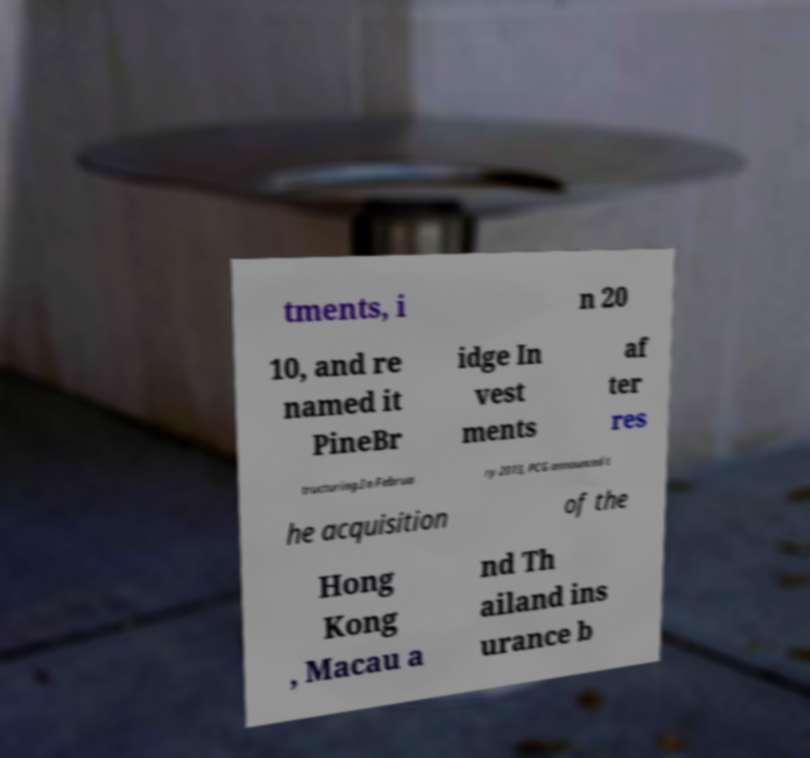Can you accurately transcribe the text from the provided image for me? tments, i n 20 10, and re named it PineBr idge In vest ments af ter res tructuring.In Februa ry 2013, PCG announced t he acquisition of the Hong Kong , Macau a nd Th ailand ins urance b 